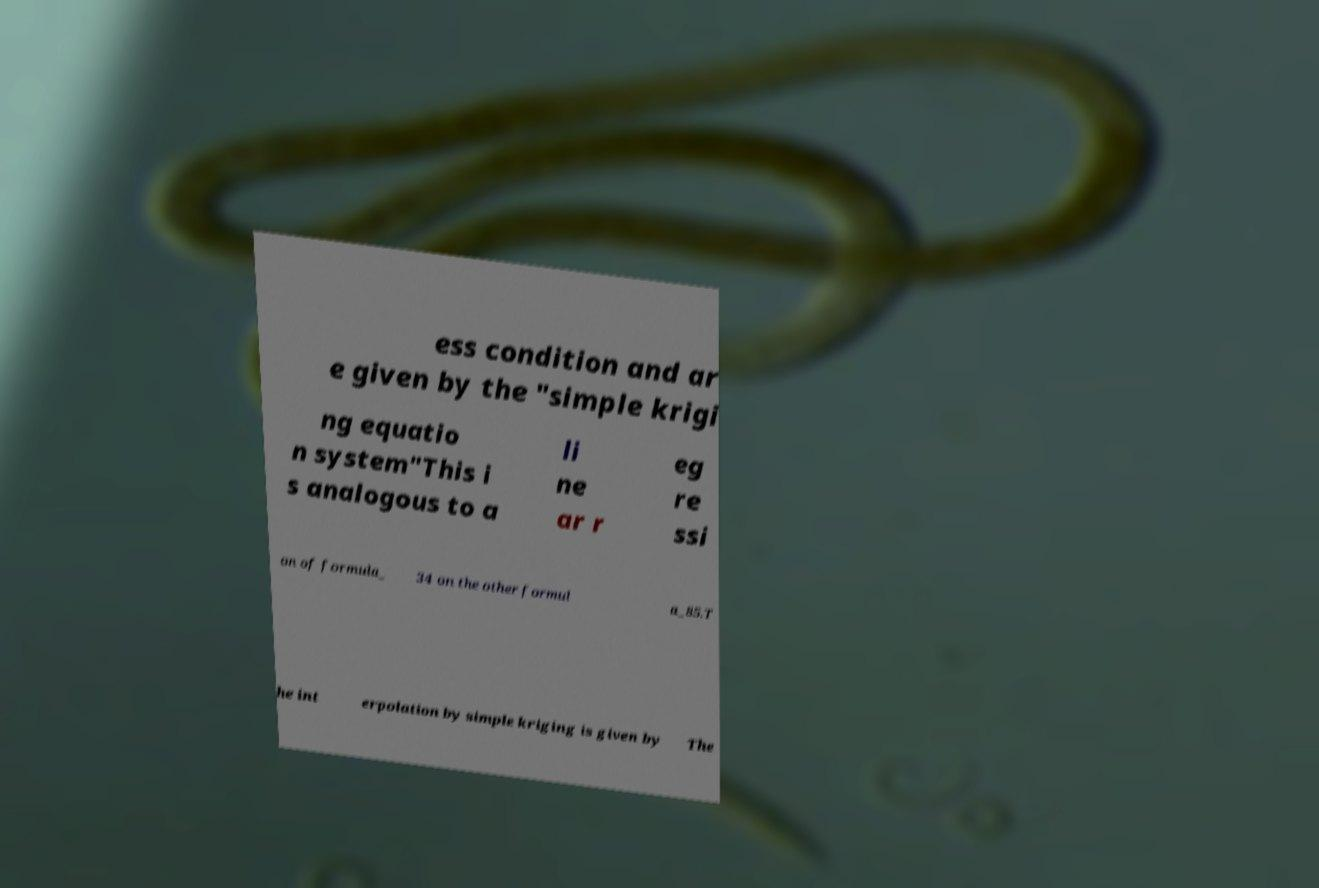Please read and relay the text visible in this image. What does it say? ess condition and ar e given by the "simple krigi ng equatio n system"This i s analogous to a li ne ar r eg re ssi on of formula_ 34 on the other formul a_85.T he int erpolation by simple kriging is given by The 